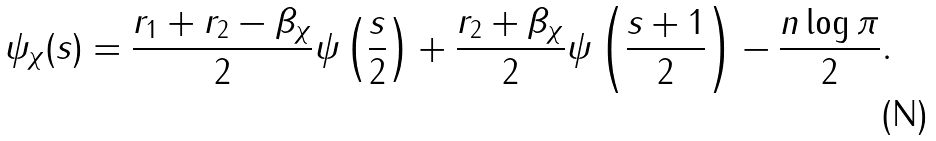<formula> <loc_0><loc_0><loc_500><loc_500>\psi _ { \chi } ( s ) = \frac { r _ { 1 } + r _ { 2 } - \beta _ { \chi } } { 2 } \psi \left ( \frac { s } { 2 } \right ) + \frac { r _ { 2 } + \beta _ { \chi } } { 2 } \psi \left ( \frac { s + 1 } { 2 } \right ) - \frac { n \log \pi } { 2 } .</formula> 